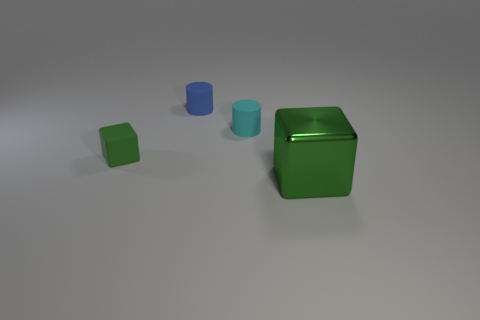Add 2 green cubes. How many objects exist? 6 Subtract all big blue rubber cubes. Subtract all small green matte blocks. How many objects are left? 3 Add 3 tiny cyan things. How many tiny cyan things are left? 4 Add 3 big cubes. How many big cubes exist? 4 Subtract 0 gray cylinders. How many objects are left? 4 